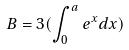Convert formula to latex. <formula><loc_0><loc_0><loc_500><loc_500>B = 3 ( \int _ { 0 } ^ { a } e ^ { x } d x )</formula> 